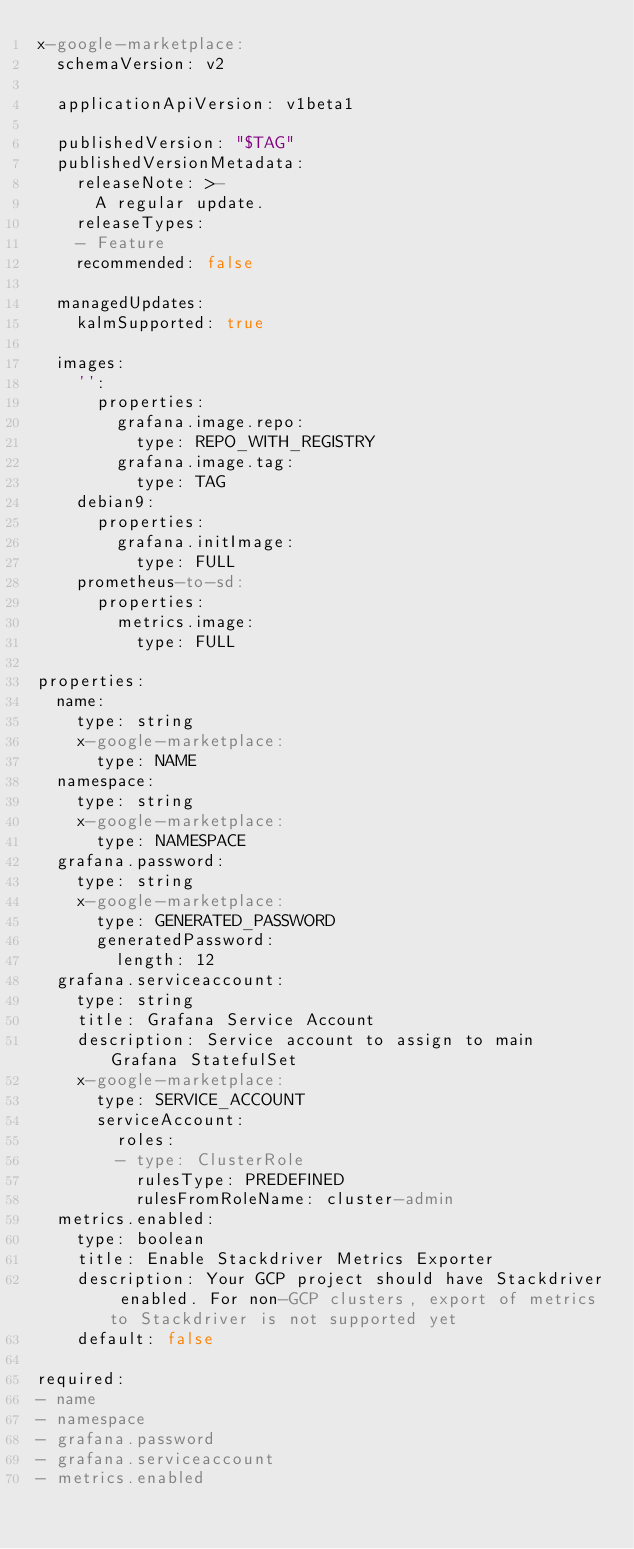Convert code to text. <code><loc_0><loc_0><loc_500><loc_500><_YAML_>x-google-marketplace:
  schemaVersion: v2

  applicationApiVersion: v1beta1

  publishedVersion: "$TAG"
  publishedVersionMetadata:
    releaseNote: >-
      A regular update.
    releaseTypes:
    - Feature
    recommended: false

  managedUpdates:
    kalmSupported: true

  images:
    '':
      properties:
        grafana.image.repo:
          type: REPO_WITH_REGISTRY
        grafana.image.tag:
          type: TAG
    debian9:
      properties:
        grafana.initImage:
          type: FULL
    prometheus-to-sd:
      properties:
        metrics.image:
          type: FULL

properties:
  name:
    type: string
    x-google-marketplace:
      type: NAME
  namespace:
    type: string
    x-google-marketplace:
      type: NAMESPACE
  grafana.password:
    type: string
    x-google-marketplace:
      type: GENERATED_PASSWORD
      generatedPassword:
        length: 12
  grafana.serviceaccount:
    type: string
    title: Grafana Service Account
    description: Service account to assign to main Grafana StatefulSet
    x-google-marketplace:
      type: SERVICE_ACCOUNT
      serviceAccount:
        roles:
        - type: ClusterRole
          rulesType: PREDEFINED
          rulesFromRoleName: cluster-admin
  metrics.enabled:
    type: boolean
    title: Enable Stackdriver Metrics Exporter
    description: Your GCP project should have Stackdriver enabled. For non-GCP clusters, export of metrics to Stackdriver is not supported yet
    default: false

required:
- name
- namespace
- grafana.password
- grafana.serviceaccount
- metrics.enabled
</code> 